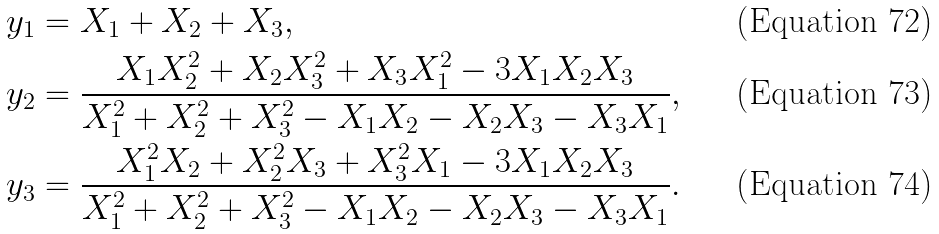<formula> <loc_0><loc_0><loc_500><loc_500>y _ { 1 } & = X _ { 1 } + X _ { 2 } + X _ { 3 } , \\ y _ { 2 } & = \frac { X _ { 1 } X _ { 2 } ^ { 2 } + X _ { 2 } X _ { 3 } ^ { 2 } + X _ { 3 } X _ { 1 } ^ { 2 } - 3 X _ { 1 } X _ { 2 } X _ { 3 } } { X _ { 1 } ^ { 2 } + X _ { 2 } ^ { 2 } + X _ { 3 } ^ { 2 } - X _ { 1 } X _ { 2 } - X _ { 2 } X _ { 3 } - X _ { 3 } X _ { 1 } } , \\ y _ { 3 } & = \frac { X _ { 1 } ^ { 2 } X _ { 2 } + X _ { 2 } ^ { 2 } X _ { 3 } + X _ { 3 } ^ { 2 } X _ { 1 } - 3 X _ { 1 } X _ { 2 } X _ { 3 } } { X _ { 1 } ^ { 2 } + X _ { 2 } ^ { 2 } + X _ { 3 } ^ { 2 } - X _ { 1 } X _ { 2 } - X _ { 2 } X _ { 3 } - X _ { 3 } X _ { 1 } } .</formula> 